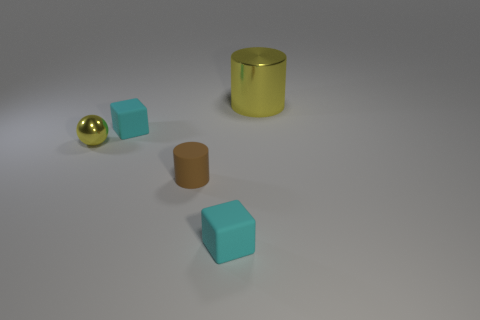Subtract all yellow cylinders. How many cylinders are left? 1 Add 2 tiny metal things. How many objects exist? 7 Subtract all cylinders. How many objects are left? 3 Subtract 1 blocks. How many blocks are left? 1 Subtract all yellow balls. How many yellow cylinders are left? 1 Subtract all cyan cubes. Subtract all brown rubber things. How many objects are left? 2 Add 1 shiny cylinders. How many shiny cylinders are left? 2 Add 4 large cyan matte objects. How many large cyan matte objects exist? 4 Subtract 0 red cylinders. How many objects are left? 5 Subtract all purple blocks. Subtract all gray cylinders. How many blocks are left? 2 